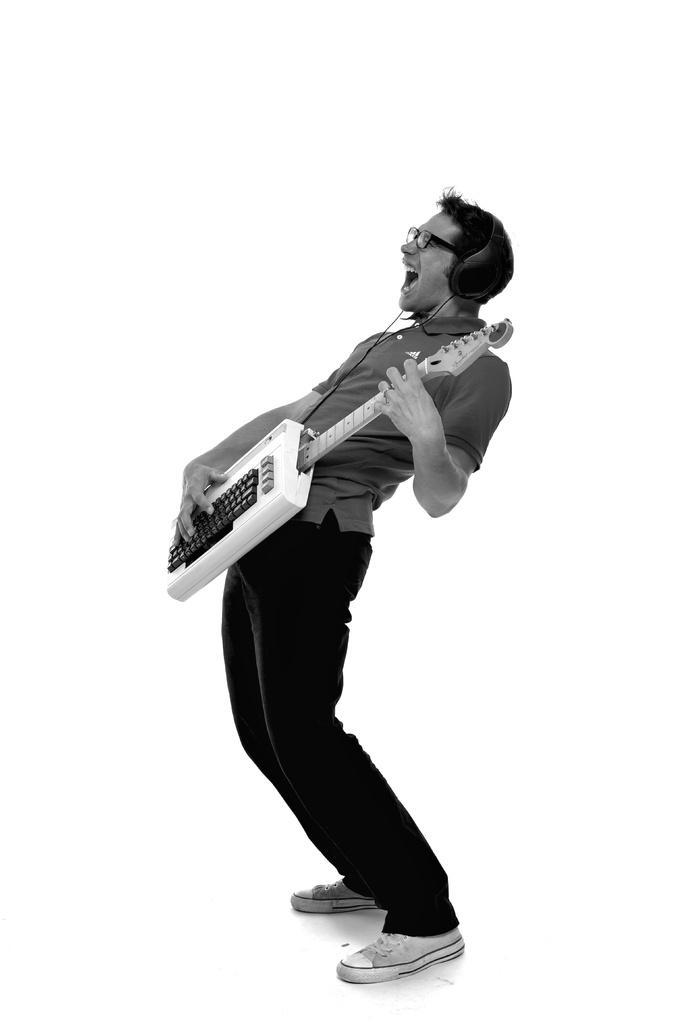In one or two sentences, can you explain what this image depicts? Here in this picture we can see a person standing over a place and he is holding and playing a musical instrument present in his hand and shouting and we can see spectacles and headset on him over there. 